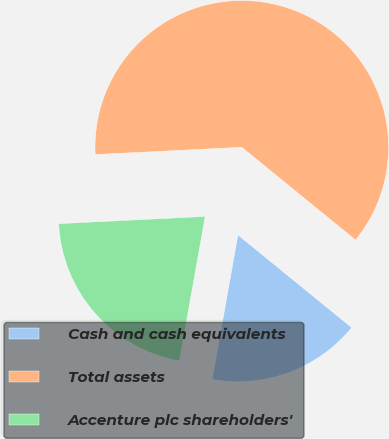Convert chart to OTSL. <chart><loc_0><loc_0><loc_500><loc_500><pie_chart><fcel>Cash and cash equivalents<fcel>Total assets<fcel>Accenture plc shareholders'<nl><fcel>16.93%<fcel>61.67%<fcel>21.4%<nl></chart> 